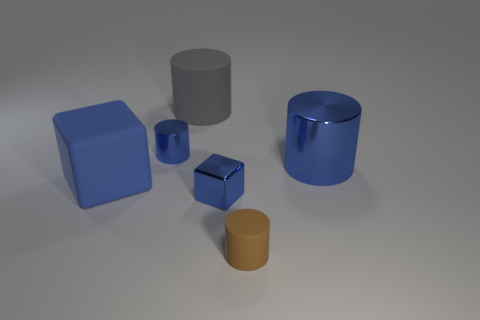Is there anything else that has the same color as the small cube?
Offer a terse response. Yes. Does the small cube have the same color as the tiny metal cylinder?
Offer a terse response. Yes. There is another small object that is the same shape as the brown matte thing; what is its material?
Your answer should be very brief. Metal. Are the small cylinder behind the large blue rubber thing and the large blue object to the right of the gray thing made of the same material?
Give a very brief answer. Yes. Are any yellow blocks visible?
Keep it short and to the point. No. Does the small thing that is on the left side of the shiny cube have the same shape as the small brown object to the right of the gray object?
Give a very brief answer. Yes. Are there any large gray balls that have the same material as the large blue block?
Give a very brief answer. No. Are the block to the left of the small shiny cube and the tiny brown cylinder made of the same material?
Offer a very short reply. Yes. Is the number of blue metallic cylinders that are to the right of the brown matte object greater than the number of big blocks that are right of the blue matte object?
Provide a short and direct response. Yes. There is a cylinder that is the same size as the brown rubber object; what color is it?
Offer a terse response. Blue. 